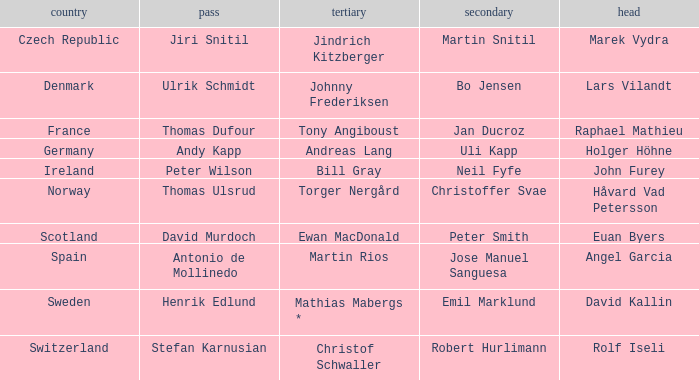When did holger höhne come in third? Andreas Lang. 